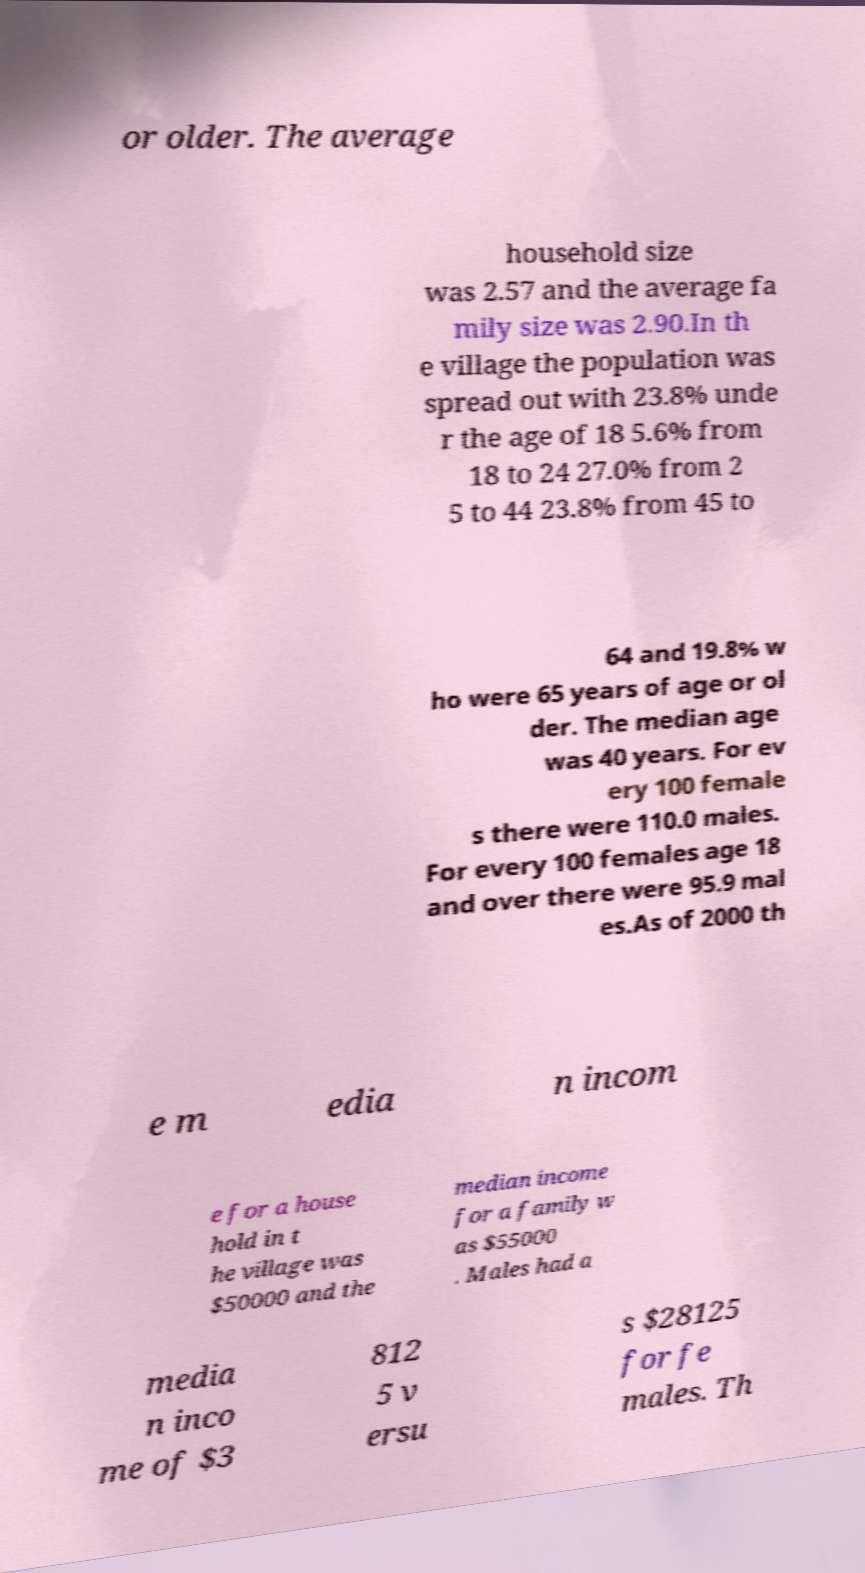Could you assist in decoding the text presented in this image and type it out clearly? or older. The average household size was 2.57 and the average fa mily size was 2.90.In th e village the population was spread out with 23.8% unde r the age of 18 5.6% from 18 to 24 27.0% from 2 5 to 44 23.8% from 45 to 64 and 19.8% w ho were 65 years of age or ol der. The median age was 40 years. For ev ery 100 female s there were 110.0 males. For every 100 females age 18 and over there were 95.9 mal es.As of 2000 th e m edia n incom e for a house hold in t he village was $50000 and the median income for a family w as $55000 . Males had a media n inco me of $3 812 5 v ersu s $28125 for fe males. Th 